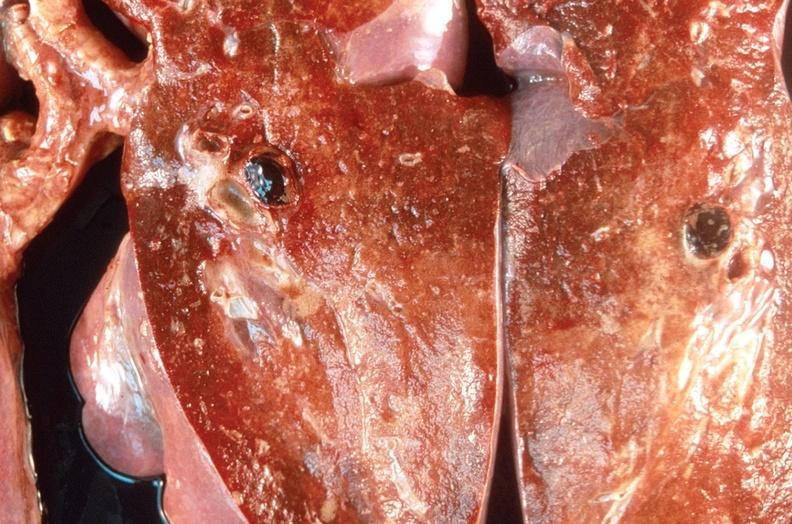does this image show pulmonary thromboemboli?
Answer the question using a single word or phrase. Yes 